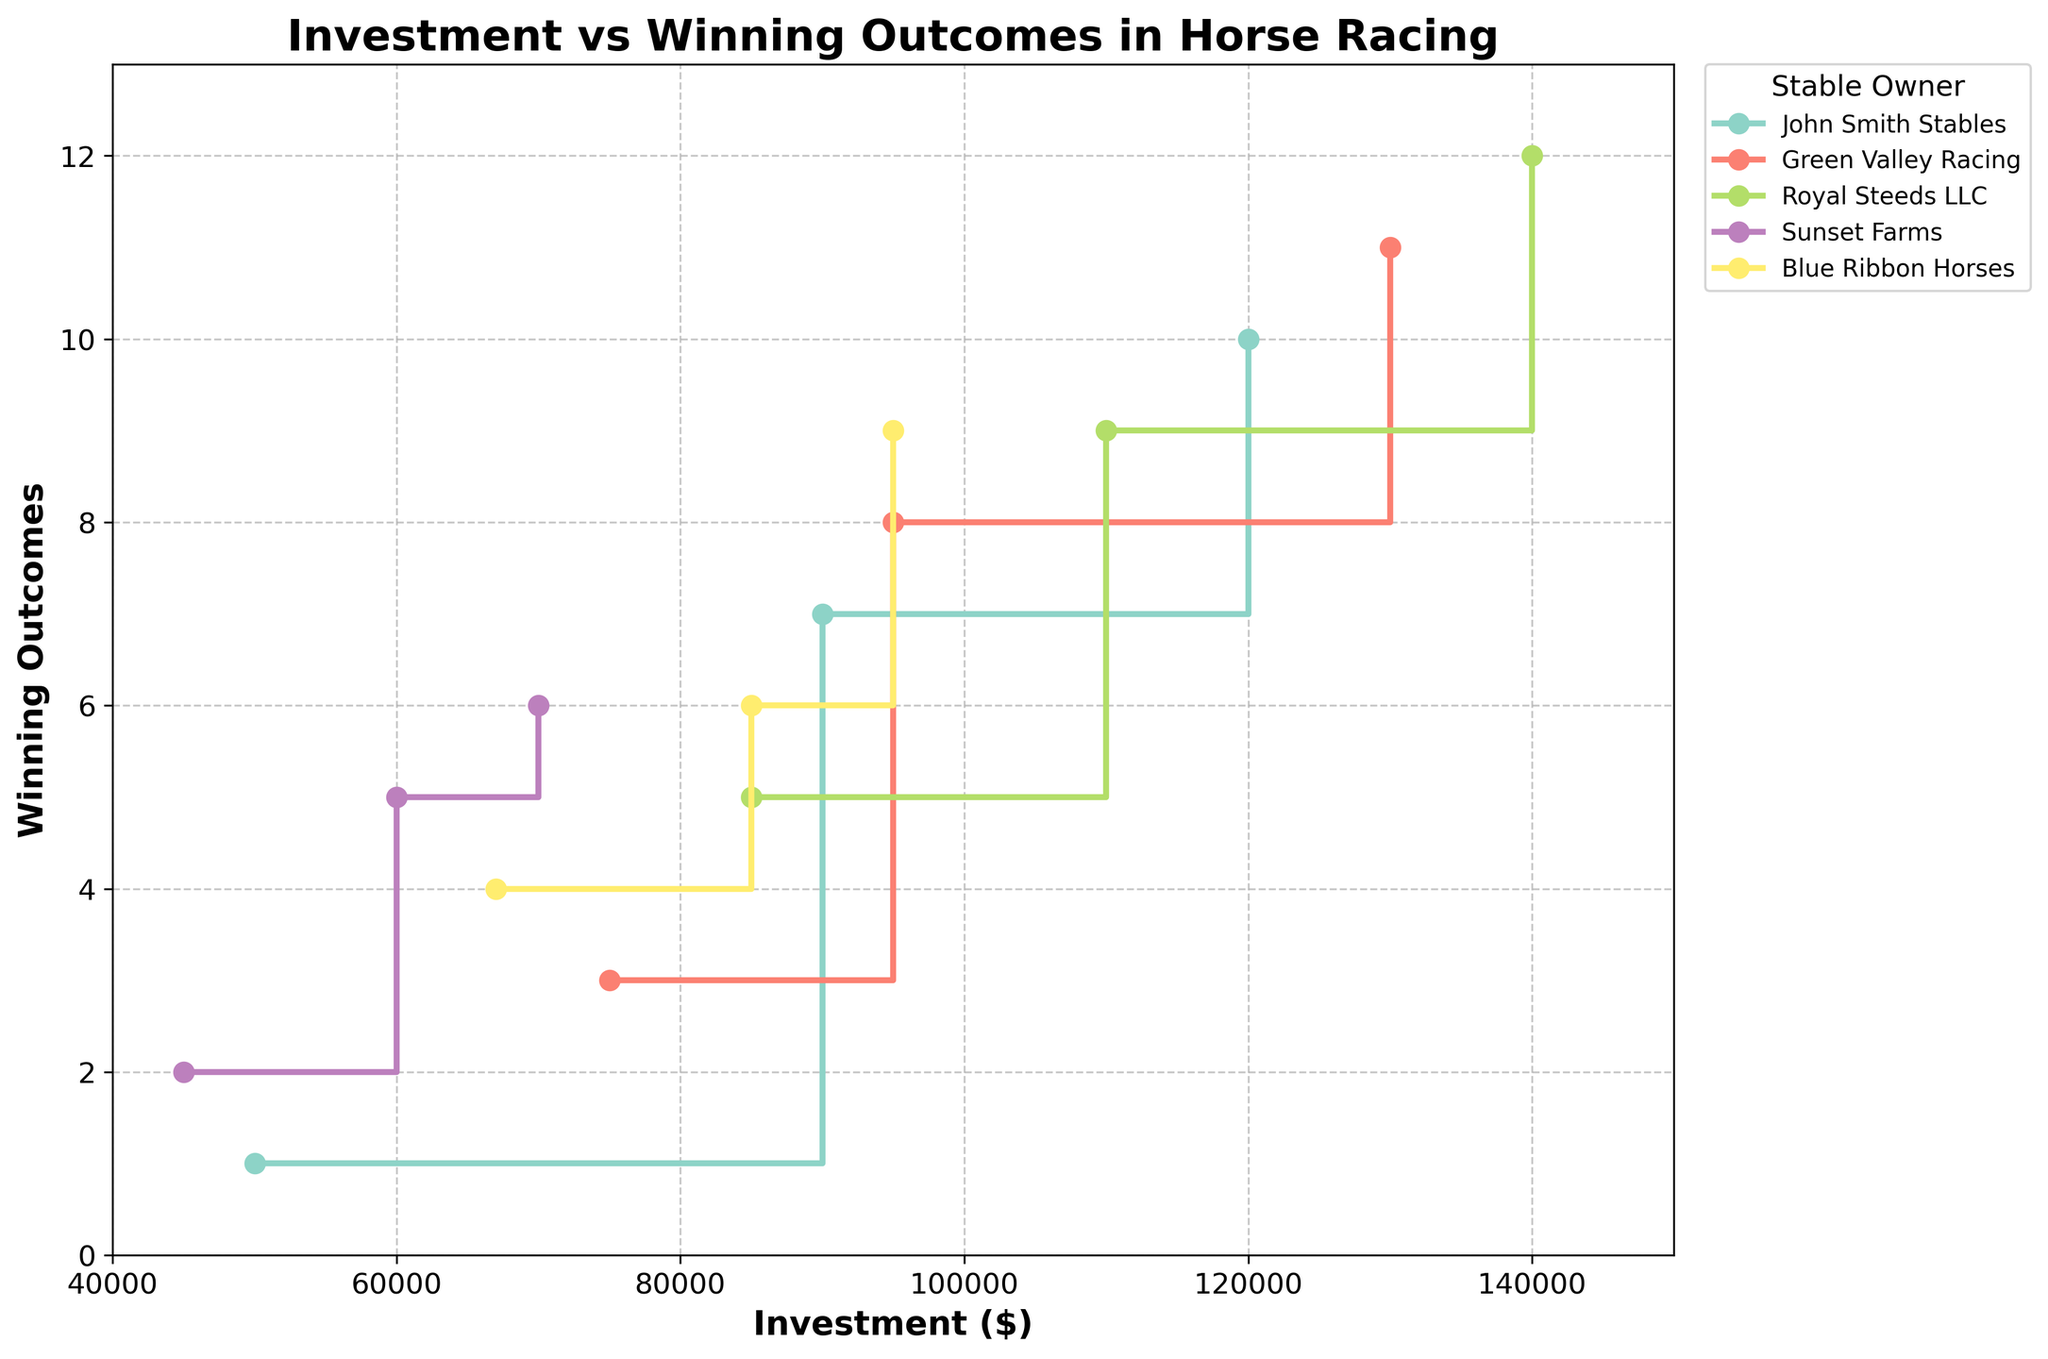Which stable had the highest investment in 2021? By examining the plot and focusing on the year 2021, we can see which stable has the highest investment level for that year. The highest investment for 2021 is $140,000 by Royal Steeds LLC.
Answer: Royal Steeds LLC What is the range of investment amounts shown on the x-axis? The x-axis represents investment amounts which range from a minimum to a maximum value. Looking at the x-axis values, the range is from $40,000 to $150,000.
Answer: $40,000 to $150,000 How many winning outcomes did John Smith Stables achieve with a $120,000 investment? By tracking John Smith Stables on the plot and finding the point where the investment is $120,000, we can determine the corresponding winning outcomes. John Smith Stables achieved 10 winning outcomes with this investment.
Answer: 10 Which stable had the most noticeable increase in winning outcomes between 2019 and 2020? To determine this, we compare the difference in winning outcomes between 2019 and 2020 for each stable. The most noticeable increase is seen for Royal Steeds LLC, which rose from 5 to 9, a difference of 4 wins.
Answer: Royal Steeds LLC Which stable shows a direct correlation between investment and winning outcomes? To assess this, we look for a stable whose winning outcomes consistently increase with investment. Royal Steeds LLC shows this direct correlation visibly on the plot.
Answer: Royal Steeds LLC What is the total number of winning outcomes for Green Valley Racing over the three years? Green Valley Racing had 3 wins in 2019, 8 in 2020, and 11 in 2021. Summing these, we get a total of 3 + 8 + 11 = 22.
Answer: 22 Is there any instance where a higher investment does not lead to more winning outcomes for a stable? By examining the step plot, we can determine if any increase in investment did not result in more winning outcomes. One such instance is Sunset Farms: a $60,000 investment in 2020 resulted in 5 wins, while a higher investment of $70,000 in 2021 resulted in only 6 wins (an increase but proportionally smaller).
Answer: Yes How does Blue Ribbon Horses' investments and outcomes compare to Sunset Farms in 2020? In 2020, Blue Ribbon Horses invested $85,000 for 6 wins, while Sunset Farms invested $60,000 for 5 wins. By comparison, Blue Ribbon Horses had a higher investment and more wins.
Answer: Blue Ribbon Horses had higher investment and more wins What is the average investment amount for Royal Steeds LLC? Royal Steeds LLC invested $85,000 in 2019, $110,000 in 2020, and $140,000 in 2021. The average can be calculated as (85000 + 110000 + 140000) / 3 = $111,667.
Answer: $111,667 